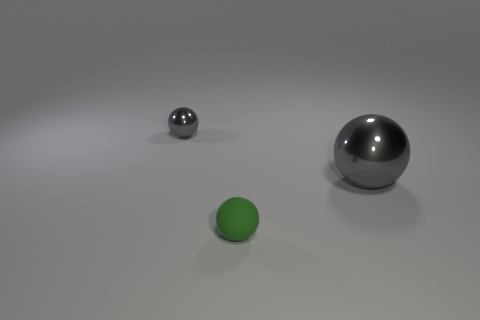What can we deduce about the environment surrounding these objects? The environment appears to be a studio-like setting with a neutral background. The lack of distinct features or additional objects implies that the focus is meant to be on the spheres themselves, perhaps emphasizing their form and material properties. 